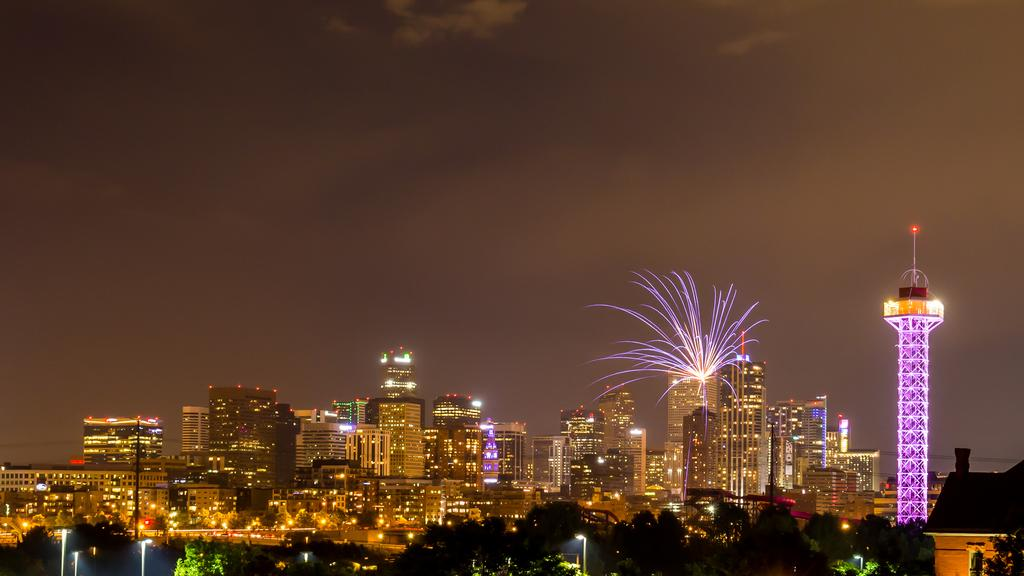What type of structures are illuminated in the image? There are buildings with lights and a tower with lights in the image. What other illuminated objects can be seen in the image? There are street lights in the image. What type of vegetation is present in the image? There are trees in the image. What can be seen in the background of the image? The sky is visible in the background of the image. What type of reward is being given to the news reporter in the image? There is no news reporter or reward present in the image. What type of peace symbol can be seen in the image? There is no peace symbol present in the image. 